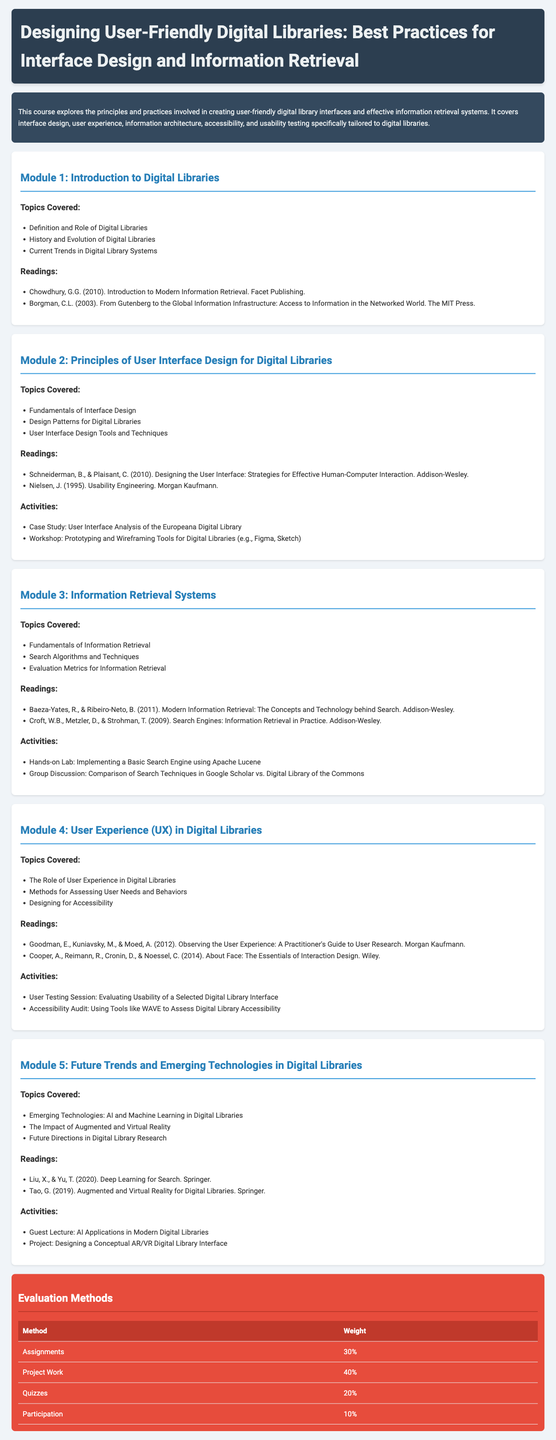What is the title of the course? The title is explicitly stated in the header of the document.
Answer: Designing User-Friendly Digital Libraries: Best Practices for Interface Design and Information Retrieval Who is the author of "Introduction to Modern Information Retrieval"? This information can be found under the readings of Module 1.
Answer: Chowdhury, G.G What percentage of the evaluation methods is assigned to Project Work? This information is detailed in the evaluation section of the document.
Answer: 40% How many modules are included in the syllabus? The main content of the syllabus is divided into distinct modules, which can be counted.
Answer: 5 What is one topic covered in Module 4? Each module details specific topics, and Module 4 has listed topics.
Answer: The Role of User Experience in Digital Libraries What tools are mentioned for prototyping in Module 2? The listed activities in Module 2 specify certain tools for interface design.
Answer: Figma, Sketch What is the weight assigned to Participation in evaluation methods? The evaluation section provides specific weights for each method clearly.
Answer: 10% Which module discusses augmented and virtual reality? Each module has a specific focus, and this can be identified from the titles.
Answer: Module 5 